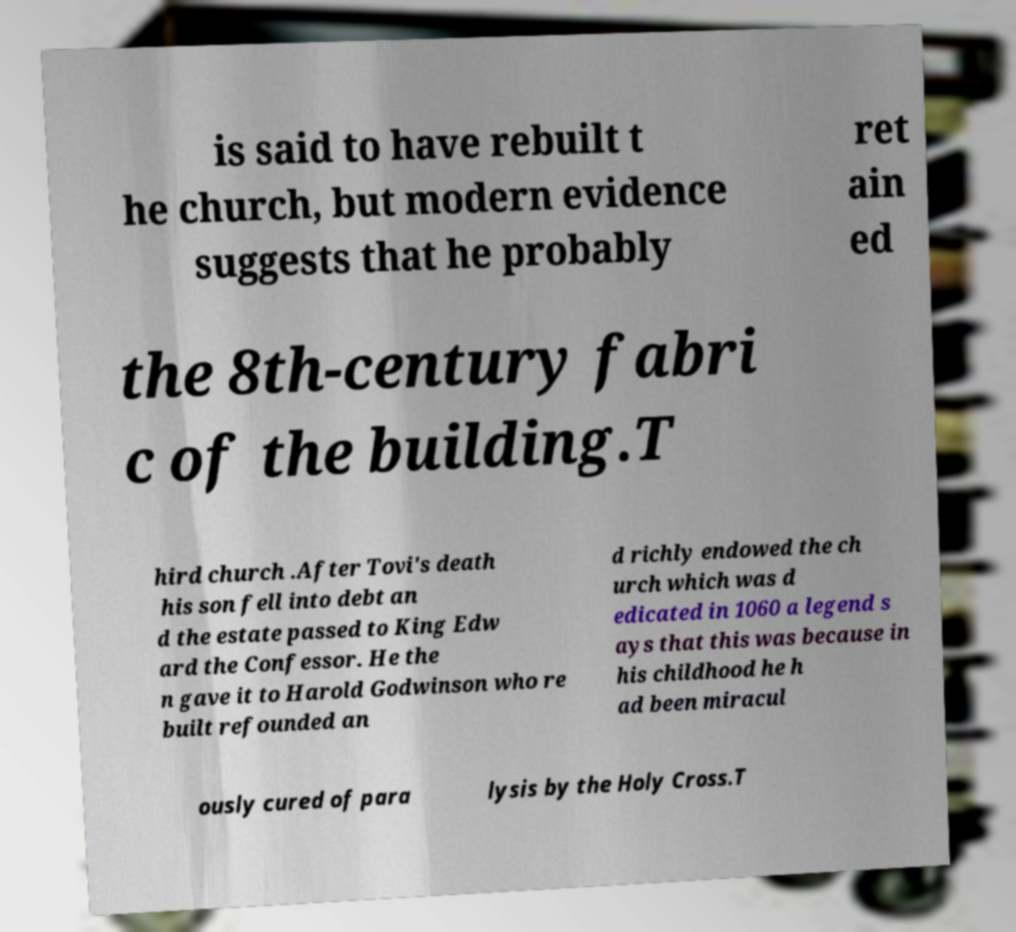For documentation purposes, I need the text within this image transcribed. Could you provide that? is said to have rebuilt t he church, but modern evidence suggests that he probably ret ain ed the 8th-century fabri c of the building.T hird church .After Tovi's death his son fell into debt an d the estate passed to King Edw ard the Confessor. He the n gave it to Harold Godwinson who re built refounded an d richly endowed the ch urch which was d edicated in 1060 a legend s ays that this was because in his childhood he h ad been miracul ously cured of para lysis by the Holy Cross.T 